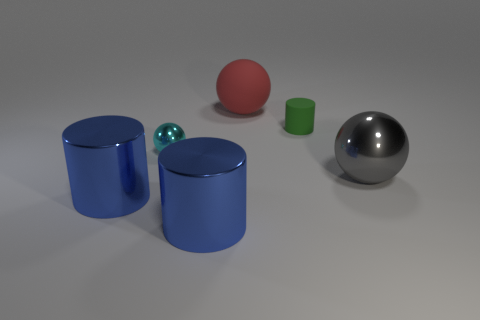How many large objects are either cyan rubber cylinders or cylinders?
Offer a very short reply. 2. There is a metal sphere that is behind the gray object; is there a rubber cylinder left of it?
Keep it short and to the point. No. Is there a tiny blue matte cylinder?
Provide a succinct answer. No. What color is the large thing behind the large sphere that is in front of the tiny green rubber object?
Give a very brief answer. Red. What is the material of the large red thing that is the same shape as the cyan object?
Ensure brevity in your answer.  Rubber. What number of metallic objects are the same size as the red rubber object?
Keep it short and to the point. 3. There is a cyan ball that is the same material as the large gray sphere; what size is it?
Give a very brief answer. Small. What number of other big matte things have the same shape as the large red object?
Provide a succinct answer. 0. What number of tiny blue cylinders are there?
Your answer should be compact. 0. Do the shiny thing behind the large metallic ball and the gray shiny thing have the same shape?
Offer a very short reply. Yes. 